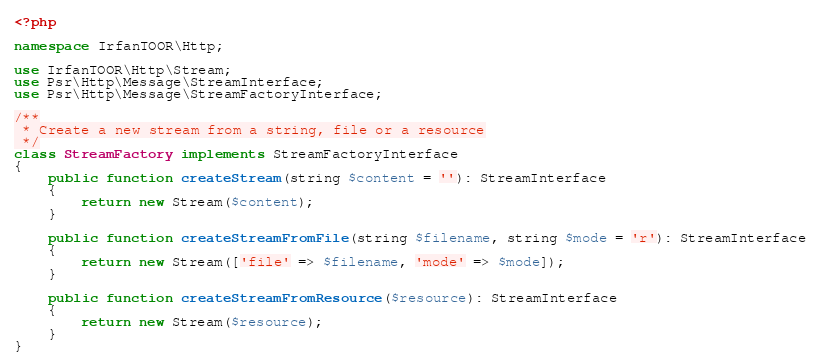Convert code to text. <code><loc_0><loc_0><loc_500><loc_500><_PHP_><?php

namespace IrfanTOOR\Http;

use IrfanTOOR\Http\Stream;
use Psr\Http\Message\StreamInterface;
use Psr\Http\Message\StreamFactoryInterface;

/**
 * Create a new stream from a string, file or a resource
 */
class StreamFactory implements StreamFactoryInterface
{
    public function createStream(string $content = ''): StreamInterface
    {
        return new Stream($content);
    }

    public function createStreamFromFile(string $filename, string $mode = 'r'): StreamInterface
    {
        return new Stream(['file' => $filename, 'mode' => $mode]);
    }

    public function createStreamFromResource($resource): StreamInterface
    {
        return new Stream($resource);
    }
}
</code> 